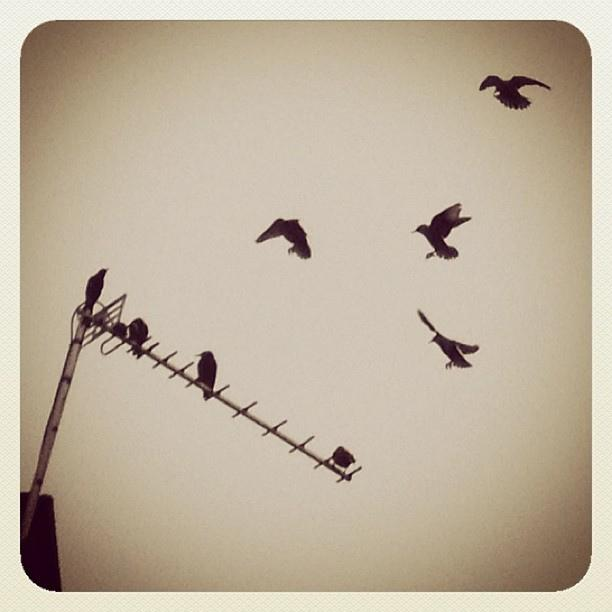Why do the birds seek high up places?

Choices:
A) like flying
B) safety
C) see more
D) exercise safety 